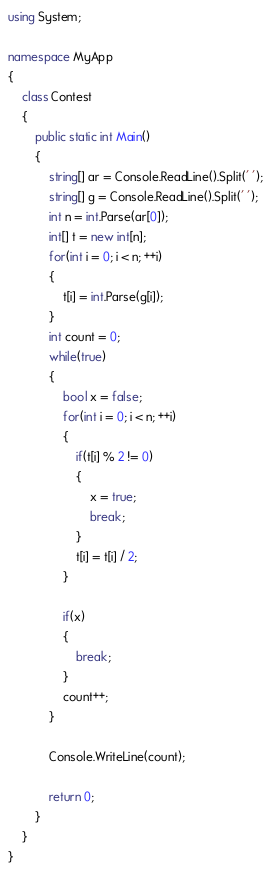<code> <loc_0><loc_0><loc_500><loc_500><_C#_>using System;

namespace MyApp
{
    class Contest
    {
        public static int Main()
        {
            string[] ar = Console.ReadLine().Split(' ');
            string[] g = Console.ReadLine().Split(' ');
            int n = int.Parse(ar[0]);
            int[] t = new int[n];
            for(int i = 0; i < n; ++i)
            {
                t[i] = int.Parse(g[i]);
            }
            int count = 0;
            while(true)
            {   
                bool x = false;
                for(int i = 0; i < n; ++i)
                {
                    if(t[i] % 2 != 0)
                    {
                        x = true;
                        break;
                    }
                    t[i] = t[i] / 2;
                }

                if(x)
                {
                    break;
                }
                count++;
            }

            Console.WriteLine(count);

            return 0;
        }
    }
}</code> 